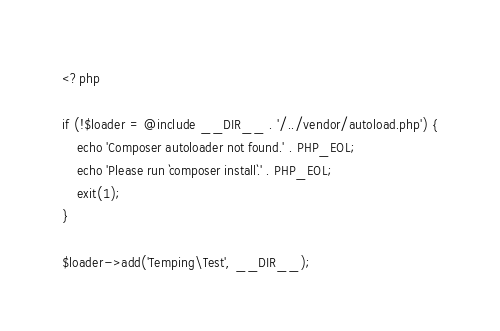Convert code to text. <code><loc_0><loc_0><loc_500><loc_500><_PHP_><?php

if (!$loader = @include __DIR__ . '/../vendor/autoload.php') {
    echo 'Composer autoloader not found.' . PHP_EOL;
    echo 'Please run `composer install`.' . PHP_EOL;
    exit(1);
}

$loader->add('Temping\Test', __DIR__);
</code> 